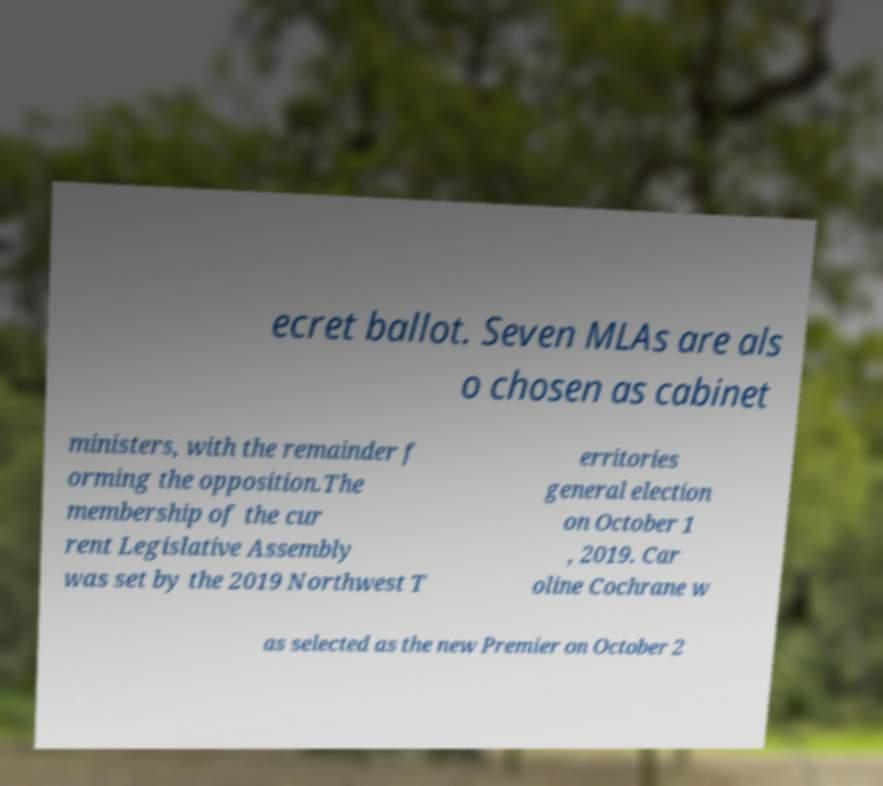Could you extract and type out the text from this image? ecret ballot. Seven MLAs are als o chosen as cabinet ministers, with the remainder f orming the opposition.The membership of the cur rent Legislative Assembly was set by the 2019 Northwest T erritories general election on October 1 , 2019. Car oline Cochrane w as selected as the new Premier on October 2 